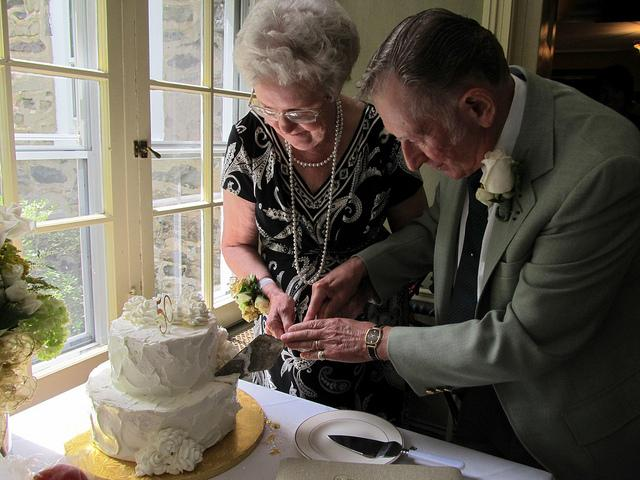Which occasion is this for? Please explain your reasoning. anniversary. There is a 50 on top of the cake.  it represents their marriage of 50 years. 